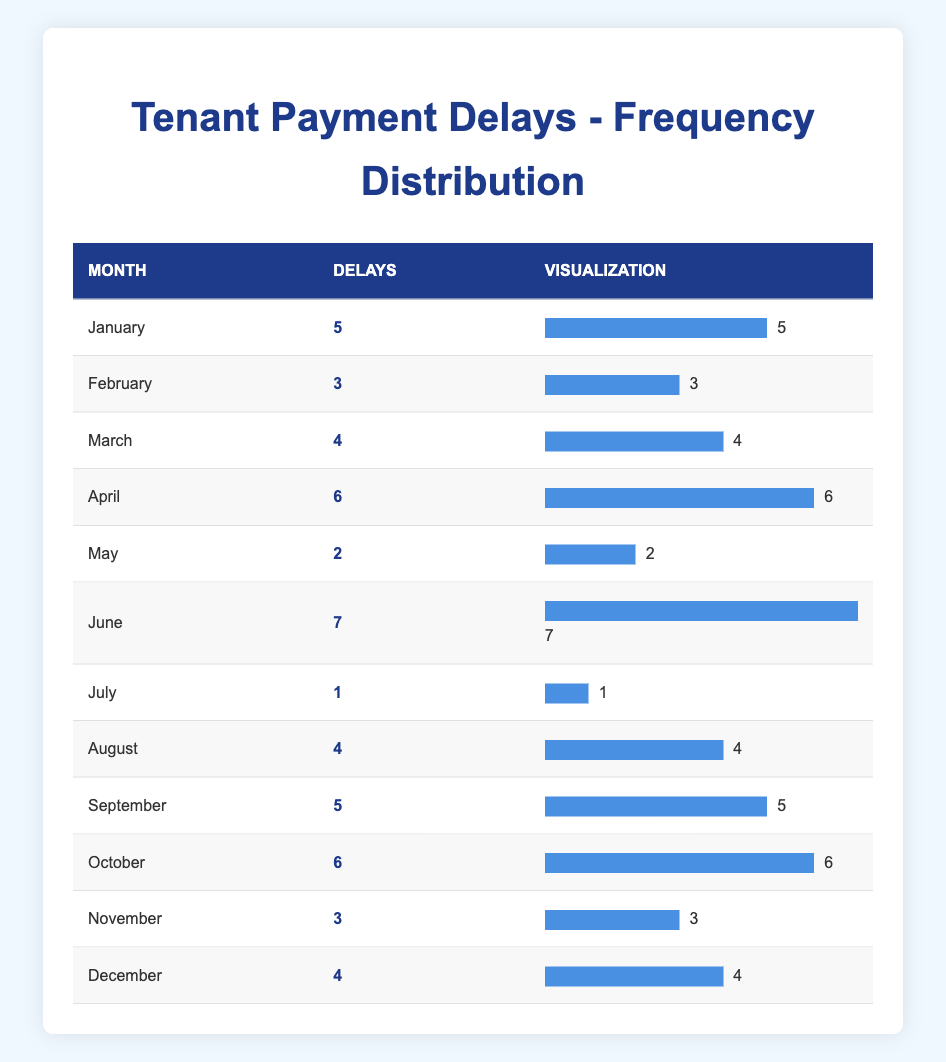What month had the highest number of payment delays? Looking at the "Delays" column, June has the highest count with 7 delays.
Answer: June How many months had fewer than 3 payment delays? Inspecting the table, May (2 delays) and July (1 delay) are the only two months with fewer than 3 delays.
Answer: 2 What is the total number of payment delays across all months? Adding the delays: 5 + 3 + 4 + 6 + 2 + 7 + 1 + 4 + 5 + 6 + 3 + 4 = 60 total delays.
Answer: 60 Is it true that there were more payment delays in the second half of the year than in the first half? In the first half (January to June), there were 27 delays (5 + 3 + 4 + 6 + 2 + 7), while in the second half (July to December), there were 33 delays (1 + 4 + 5 + 6 + 3 + 4). Therefore, the statement is true.
Answer: Yes Which month had the lowest number of payment delays and what was that number? The table shows July has the lowest number with only 1 delay.
Answer: July, 1 What is the average number of payment delays per month? To find the average, sum the delays (60) and divide by the number of months (12): 60 / 12 = 5.
Answer: 5 How many months had 4 or more payment delays? By counting the months with delays of 4 or more: January (5), March (4), April (6), June (7), August (4), September (5), October (6), December (4). That's 8 months.
Answer: 8 Was there a month with exactly 5 payment delays? Yes, January and September both had exactly 5 payment delays.
Answer: Yes What is the difference in payment delays between the month with the most delays and the month with the least delays? June had the most delays at 7, and July had the least at 1. The difference is 7 - 1 = 6.
Answer: 6 